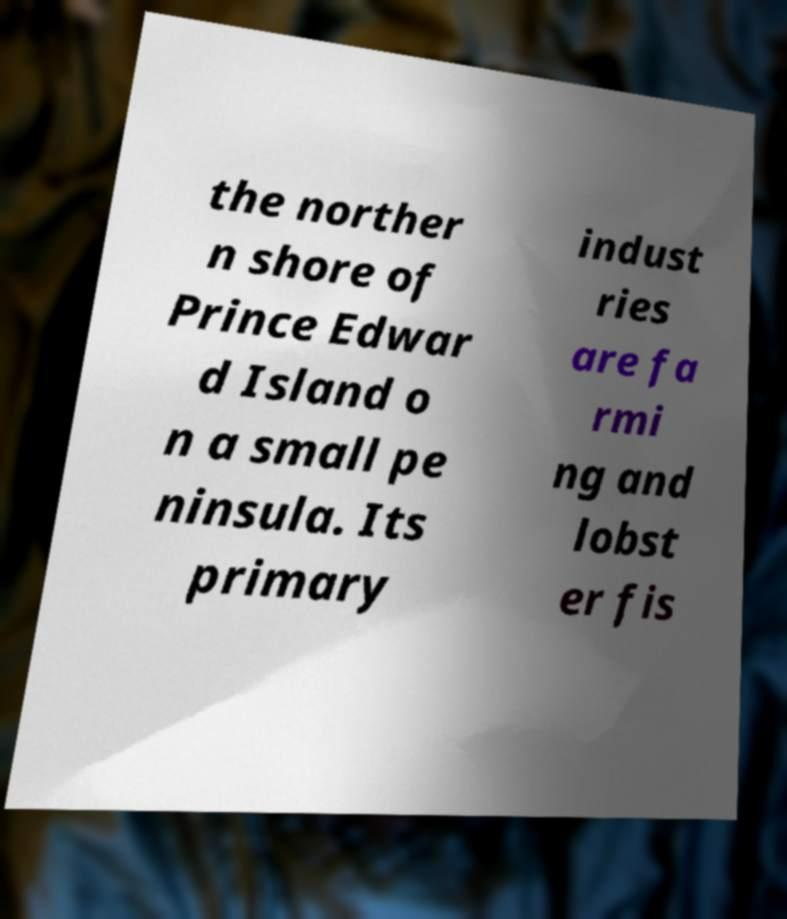Please read and relay the text visible in this image. What does it say? the norther n shore of Prince Edwar d Island o n a small pe ninsula. Its primary indust ries are fa rmi ng and lobst er fis 